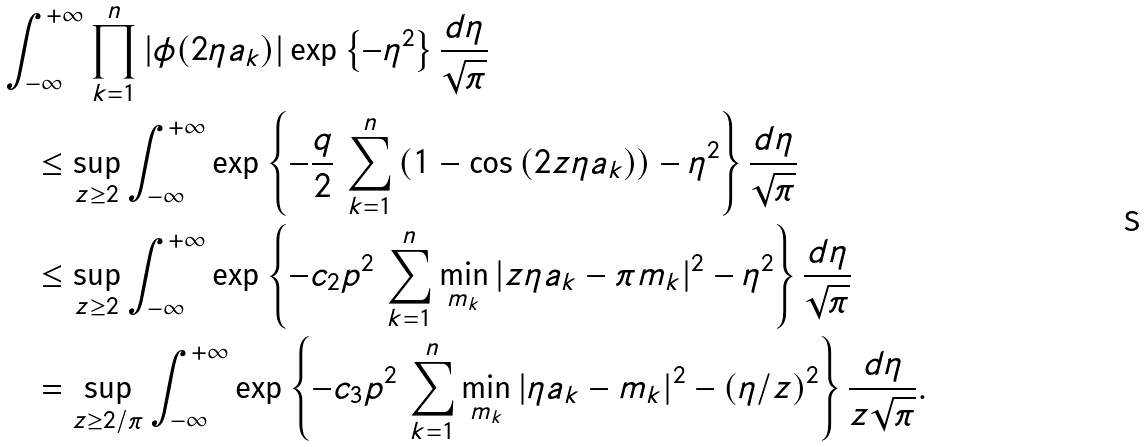Convert formula to latex. <formula><loc_0><loc_0><loc_500><loc_500>& \int _ { - \infty } ^ { + \infty } \prod _ { k = 1 } ^ { n } | \phi ( 2 \eta a _ { k } ) | \exp \left \{ - \eta ^ { 2 } \right \} \frac { d \eta } { \sqrt { \pi } } \\ & \quad \leq \sup _ { z \geq 2 } \int _ { - \infty } ^ { + \infty } \exp \left \{ - \frac { q } { 2 } \, \sum _ { k = 1 } ^ { n } \left ( 1 - \cos \left ( 2 z \eta a _ { k } \right ) \right ) - \eta ^ { 2 } \right \} \frac { d \eta } { \sqrt { \pi } } \\ & \quad \leq \sup _ { z \geq 2 } \int _ { - \infty } ^ { + \infty } \exp \left \{ - c _ { 2 } p ^ { 2 } \, \sum _ { k = 1 } ^ { n } \min _ { m _ { k } } | z \eta a _ { k } - \pi m _ { k } | ^ { 2 } - \eta ^ { 2 } \right \} \frac { d \eta } { \sqrt { \pi } } \\ & \quad = \sup _ { z \geq 2 / \pi } \int _ { - \infty } ^ { + \infty } \exp \left \{ - c _ { 3 } p ^ { 2 } \, \sum _ { k = 1 } ^ { n } \min _ { m _ { k } } | \eta a _ { k } - m _ { k } | ^ { 2 } - ( \eta / z ) ^ { 2 } \right \} \frac { d \eta } { z \sqrt { \pi } } .</formula> 